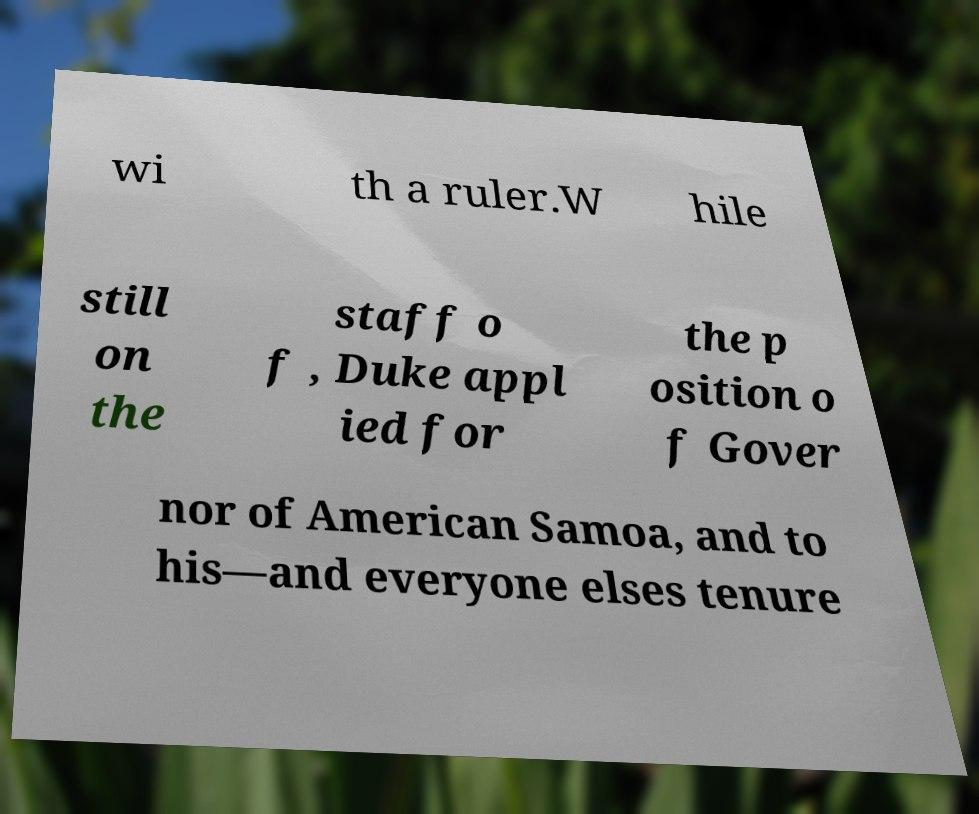Can you read and provide the text displayed in the image?This photo seems to have some interesting text. Can you extract and type it out for me? wi th a ruler.W hile still on the staff o f , Duke appl ied for the p osition o f Gover nor of American Samoa, and to his—and everyone elses tenure 